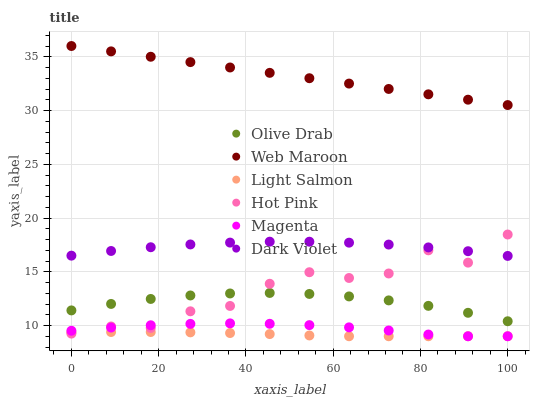Does Light Salmon have the minimum area under the curve?
Answer yes or no. Yes. Does Web Maroon have the maximum area under the curve?
Answer yes or no. Yes. Does Hot Pink have the minimum area under the curve?
Answer yes or no. No. Does Hot Pink have the maximum area under the curve?
Answer yes or no. No. Is Web Maroon the smoothest?
Answer yes or no. Yes. Is Hot Pink the roughest?
Answer yes or no. Yes. Is Hot Pink the smoothest?
Answer yes or no. No. Is Web Maroon the roughest?
Answer yes or no. No. Does Light Salmon have the lowest value?
Answer yes or no. Yes. Does Hot Pink have the lowest value?
Answer yes or no. No. Does Web Maroon have the highest value?
Answer yes or no. Yes. Does Hot Pink have the highest value?
Answer yes or no. No. Is Olive Drab less than Dark Violet?
Answer yes or no. Yes. Is Web Maroon greater than Dark Violet?
Answer yes or no. Yes. Does Light Salmon intersect Hot Pink?
Answer yes or no. Yes. Is Light Salmon less than Hot Pink?
Answer yes or no. No. Is Light Salmon greater than Hot Pink?
Answer yes or no. No. Does Olive Drab intersect Dark Violet?
Answer yes or no. No. 